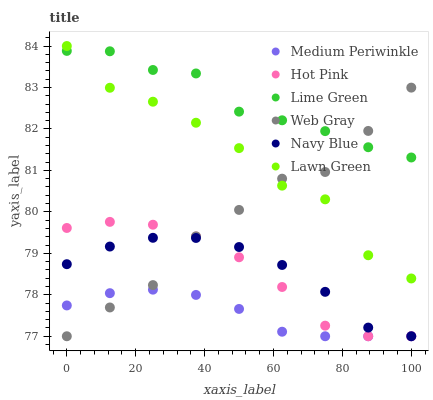Does Medium Periwinkle have the minimum area under the curve?
Answer yes or no. Yes. Does Lime Green have the maximum area under the curve?
Answer yes or no. Yes. Does Web Gray have the minimum area under the curve?
Answer yes or no. No. Does Web Gray have the maximum area under the curve?
Answer yes or no. No. Is Medium Periwinkle the smoothest?
Answer yes or no. Yes. Is Lawn Green the roughest?
Answer yes or no. Yes. Is Web Gray the smoothest?
Answer yes or no. No. Is Web Gray the roughest?
Answer yes or no. No. Does Web Gray have the lowest value?
Answer yes or no. Yes. Does Lime Green have the lowest value?
Answer yes or no. No. Does Lawn Green have the highest value?
Answer yes or no. Yes. Does Web Gray have the highest value?
Answer yes or no. No. Is Hot Pink less than Lime Green?
Answer yes or no. Yes. Is Lime Green greater than Hot Pink?
Answer yes or no. Yes. Does Navy Blue intersect Medium Periwinkle?
Answer yes or no. Yes. Is Navy Blue less than Medium Periwinkle?
Answer yes or no. No. Is Navy Blue greater than Medium Periwinkle?
Answer yes or no. No. Does Hot Pink intersect Lime Green?
Answer yes or no. No. 